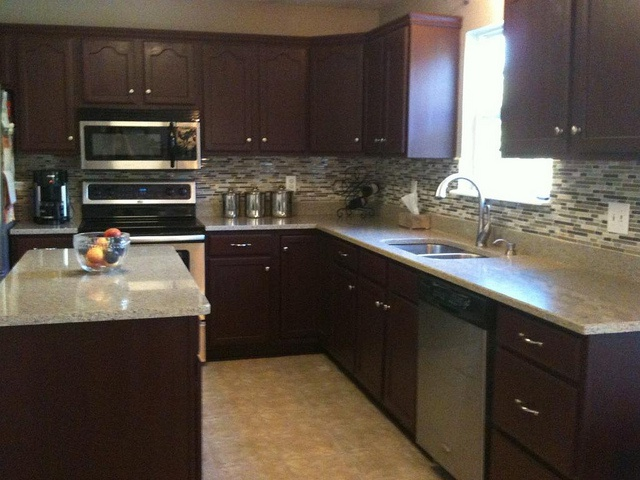Describe the objects in this image and their specific colors. I can see oven in gray, black, white, and darkgray tones, microwave in gray, black, and beige tones, refrigerator in gray, black, darkgray, and darkblue tones, bowl in gray, darkgray, and tan tones, and sink in gray and darkgray tones in this image. 